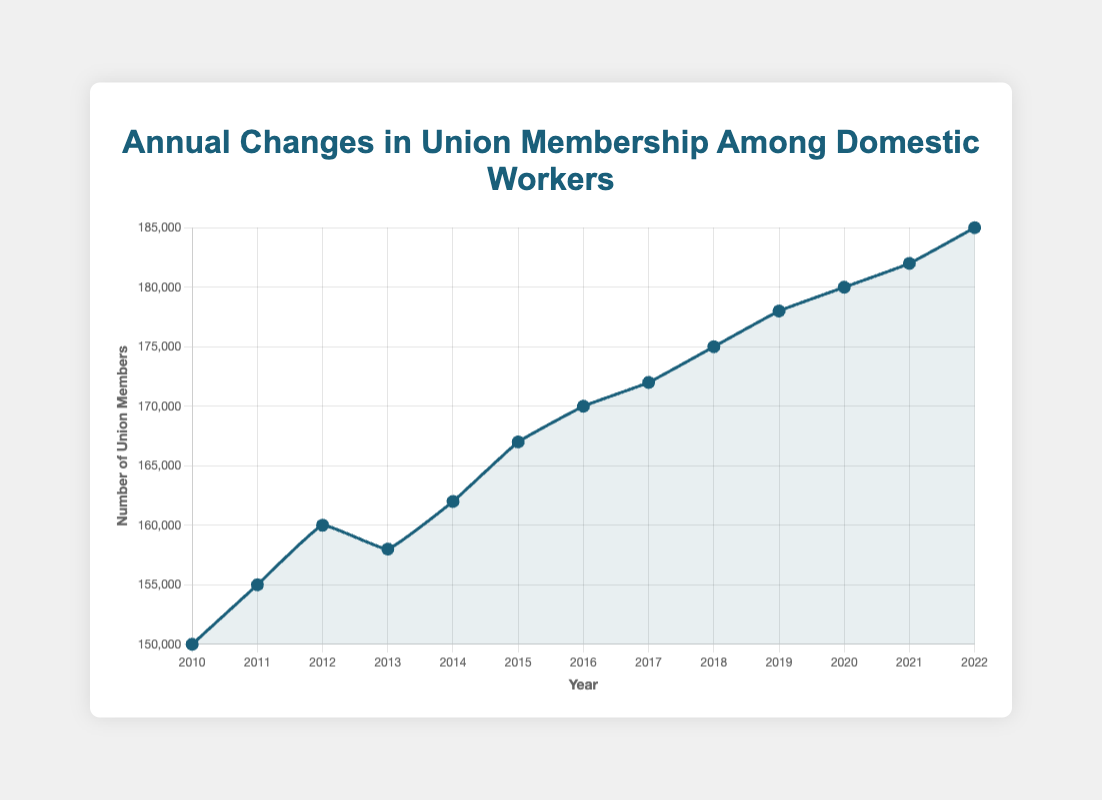What is the highest union membership value recorded in the data? The highest value can be found by visually scanning the line chart for the peak point. The highest point on the chart corresponds to the year 2022 with a membership value of 185,000.
Answer: 185,000 In which year did union membership decrease compared to the previous year? To find the year with a decrease, look for the segment in the line chart that slopes downwards. The plot shows a decrease from 2012 to 2013.
Answer: 2013 What is the average union membership from 2010 to 2015? Add the membership values from 2010 (150,000), 2011 (155,000), 2012 (160,000), 2013 (158,000), 2014 (162,000), and 2015 (167,000), then divide by the number of years (6). The sum is 952,000. The average is 952,000 / 6 = 158,667.
Answer: 158,667 Compare the union membership growth between 2018 and 2019 with the growth between 2019 and 2020. Which period shows higher growth? Calculate the differences: From 2018 (175,000) to 2019 (178,000), the growth is 178,000 - 175,000 = 3,000. From 2019 (178,000) to 2020 (180,000), the growth is 180,000 - 178,000 = 2,000.
Answer: 2018-2019 What was the rate of increase in union membership from 2010 to 2022? The membership in 2010 was 150,000, and in 2022, it was 185,000. The increase is 185,000 - 150,000 = 35,000 over 12 years. The rate of increase is (35,000 / 150,000) * 100% ≈ 23.33%.
Answer: 23.33% From 2015 to 2018, which year saw the highest increase in union membership? Calculate yearly differences: 2016 (170,000) - 2015 (167,000) = 3,000; 2017 (172,000) - 2016 (170,000) = 2,000; 2018 (175,000) - 2017 (172,000) = 3,000. The years 2016 and 2018 both had the highest increase of 3,000 members.
Answer: 2016 and 2018 What's the difference in union membership between the years 2010 and 2022? Subtract the 2010 membership (150,000) from the 2022 membership (185,000). The difference is 185,000 - 150,000 = 35,000 members.
Answer: 35,000 